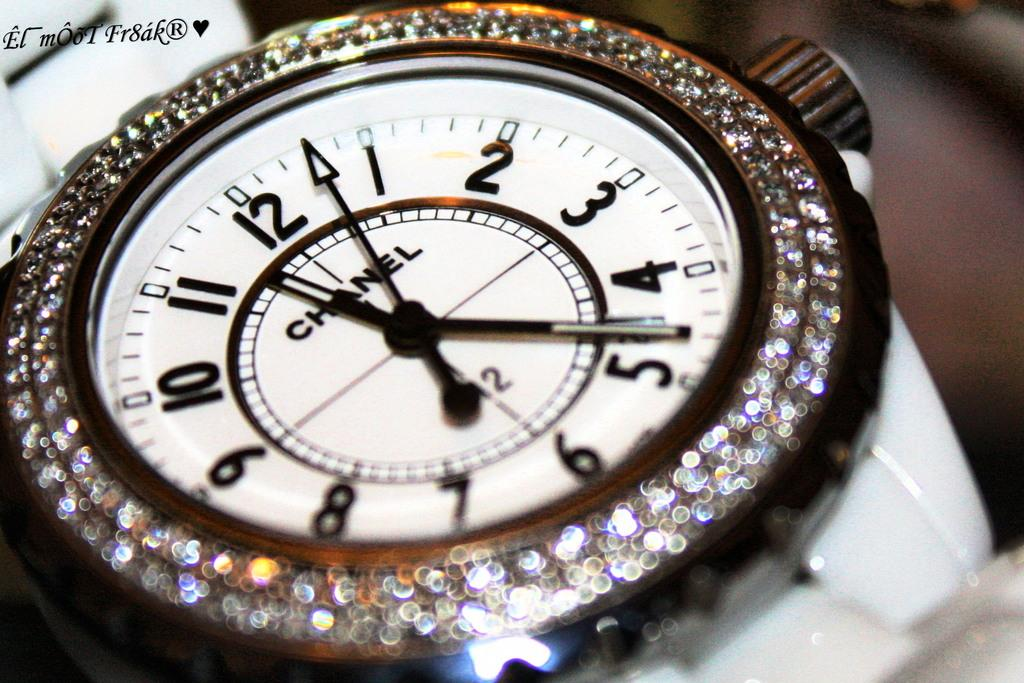<image>
Present a compact description of the photo's key features. A Chanel watch displaying the time at 11:23. 